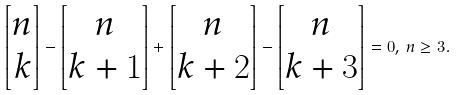Convert formula to latex. <formula><loc_0><loc_0><loc_500><loc_500>\left [ \begin{matrix} n \\ k \end{matrix} \right ] - \left [ \begin{matrix} n \\ k + 1 \end{matrix} \right ] + \left [ \begin{matrix} n \\ k + 2 \end{matrix} \right ] - \left [ \begin{matrix} n \\ k + 3 \end{matrix} \right ] = 0 , \, n \geq 3 .</formula> 